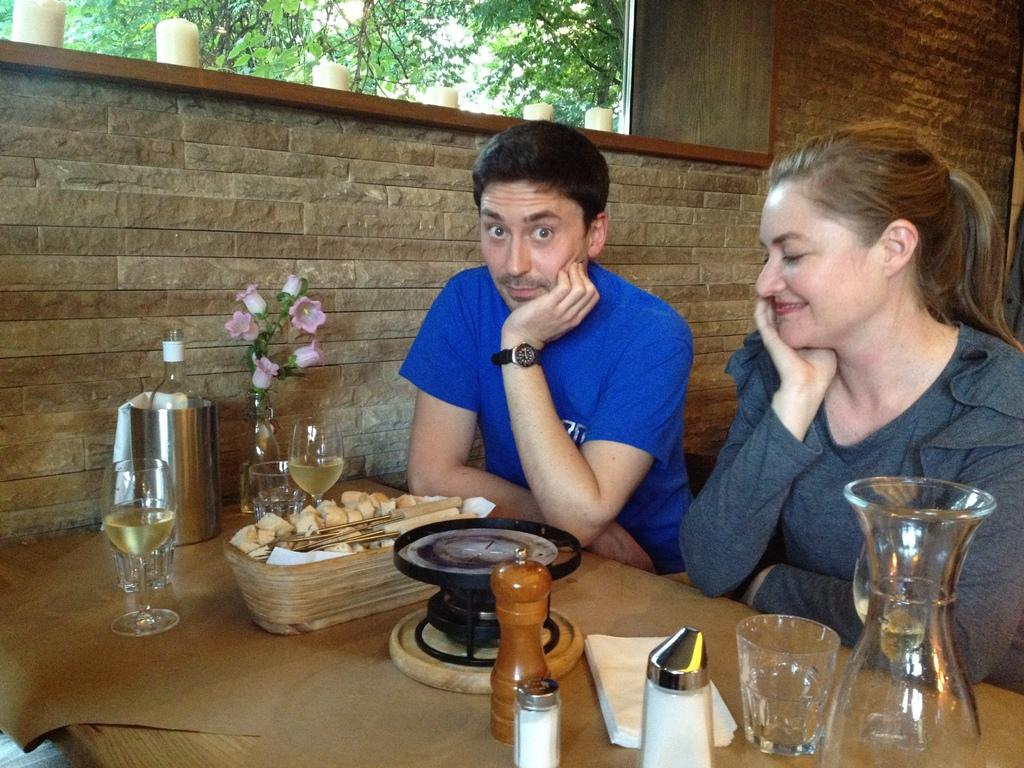What are the people in the image doing? The people in the image are sitting on chairs. Where are the people located in relation to the table? The people are in front of a table. What is on the table in the image? There is a glass of wine and a flower vase on the table. What can be seen in the background of the image? Trees are visible behind the people. What type of lock is used to secure the business in the image? There is no business or lock present in the image; it features people sitting in front of a table with a glass of wine and a flower vase. 